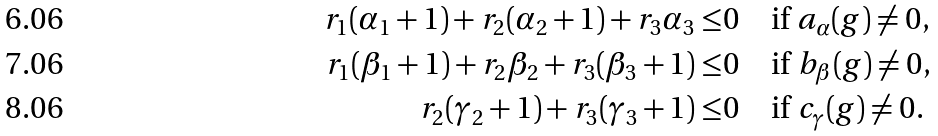<formula> <loc_0><loc_0><loc_500><loc_500>r _ { 1 } ( \alpha _ { 1 } + 1 ) + r _ { 2 } ( \alpha _ { 2 } + 1 ) + r _ { 3 } \alpha _ { 3 } \leq & 0 \quad \text {if } a _ { \alpha } ( g ) \neq 0 , \\ r _ { 1 } ( \beta _ { 1 } + 1 ) + r _ { 2 } \beta _ { 2 } + r _ { 3 } ( \beta _ { 3 } + 1 ) \leq & 0 \quad \text {if } b _ { \beta } ( g ) \neq 0 , \\ r _ { 2 } ( \gamma _ { 2 } + 1 ) + r _ { 3 } ( \gamma _ { 3 } + 1 ) \leq & 0 \quad \text {if } c _ { \gamma } ( g ) \neq 0 .</formula> 